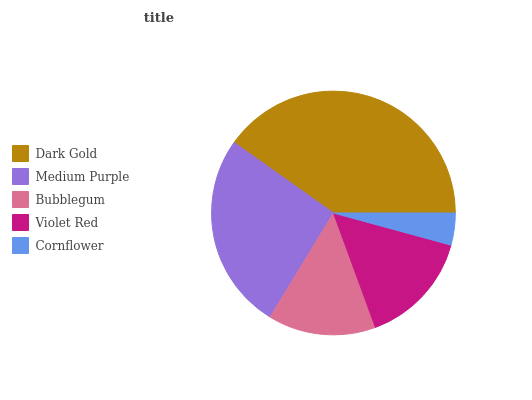Is Cornflower the minimum?
Answer yes or no. Yes. Is Dark Gold the maximum?
Answer yes or no. Yes. Is Medium Purple the minimum?
Answer yes or no. No. Is Medium Purple the maximum?
Answer yes or no. No. Is Dark Gold greater than Medium Purple?
Answer yes or no. Yes. Is Medium Purple less than Dark Gold?
Answer yes or no. Yes. Is Medium Purple greater than Dark Gold?
Answer yes or no. No. Is Dark Gold less than Medium Purple?
Answer yes or no. No. Is Violet Red the high median?
Answer yes or no. Yes. Is Violet Red the low median?
Answer yes or no. Yes. Is Dark Gold the high median?
Answer yes or no. No. Is Cornflower the low median?
Answer yes or no. No. 